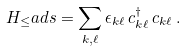Convert formula to latex. <formula><loc_0><loc_0><loc_500><loc_500>H _ { \leq } a d s = \sum _ { { k } , \ell } \epsilon _ { k \ell } \, c ^ { \dagger } _ { k \ell } \, c _ { k \ell } \, .</formula> 